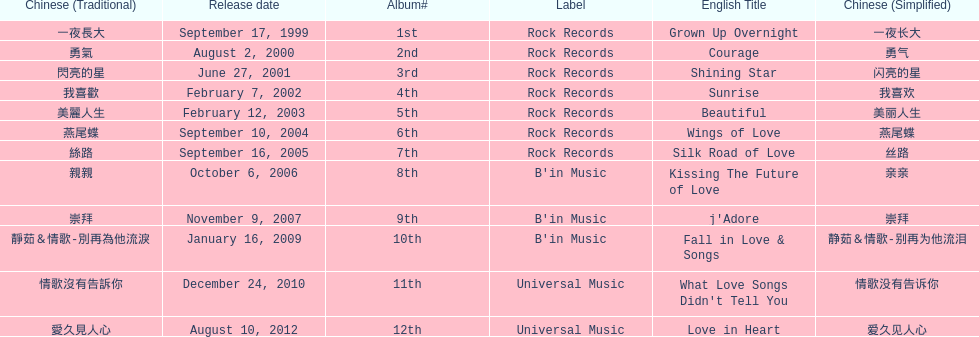Was the album beautiful released before the album love in heart? Yes. 